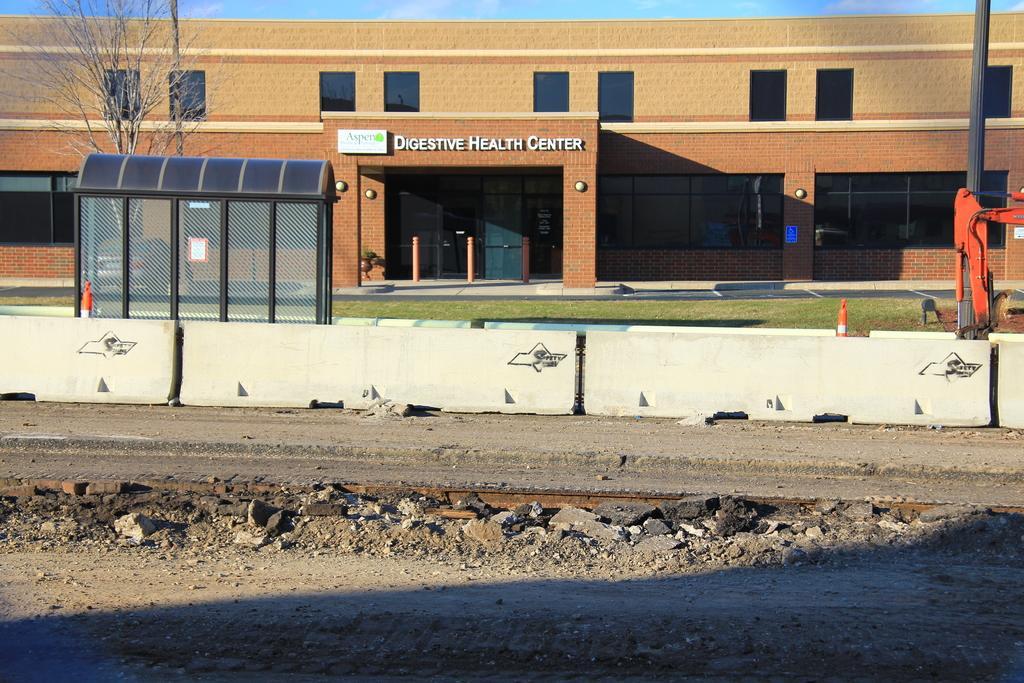How would you summarize this image in a sentence or two? This is an outside view. At the bottom, I can see the ground. On the right side there is a pole. On the left side there is box made up of net. At the back of it there is a tree. In the Background there is a building. At the top of the image, I can see the sky. 